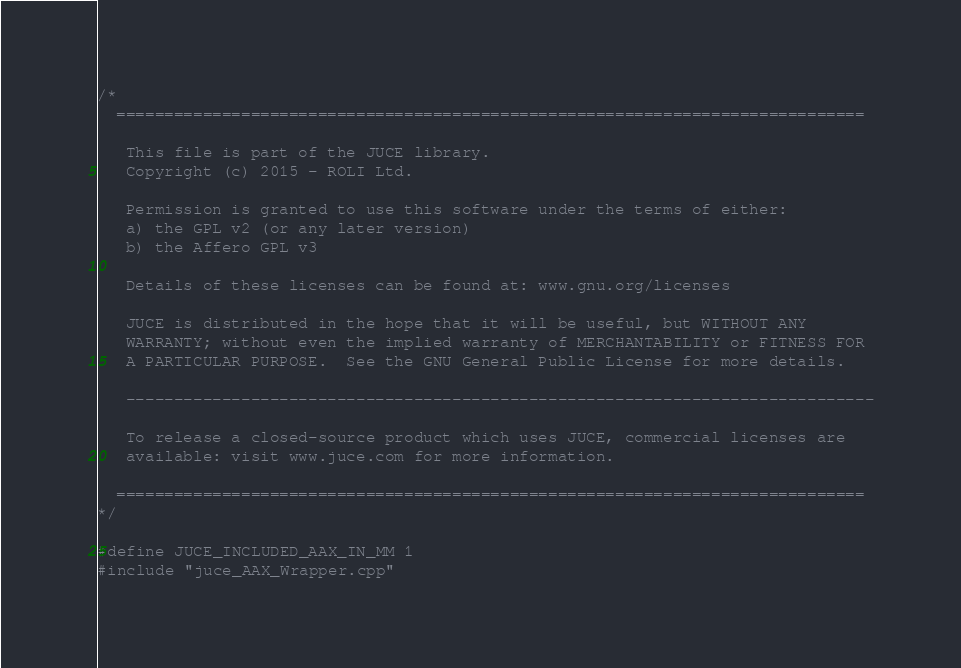Convert code to text. <code><loc_0><loc_0><loc_500><loc_500><_ObjectiveC_>/*
  ==============================================================================

   This file is part of the JUCE library.
   Copyright (c) 2015 - ROLI Ltd.

   Permission is granted to use this software under the terms of either:
   a) the GPL v2 (or any later version)
   b) the Affero GPL v3

   Details of these licenses can be found at: www.gnu.org/licenses

   JUCE is distributed in the hope that it will be useful, but WITHOUT ANY
   WARRANTY; without even the implied warranty of MERCHANTABILITY or FITNESS FOR
   A PARTICULAR PURPOSE.  See the GNU General Public License for more details.

   ------------------------------------------------------------------------------

   To release a closed-source product which uses JUCE, commercial licenses are
   available: visit www.juce.com for more information.

  ==============================================================================
*/

#define JUCE_INCLUDED_AAX_IN_MM 1
#include "juce_AAX_Wrapper.cpp"
</code> 